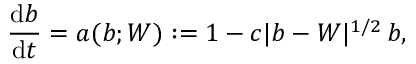Convert formula to latex. <formula><loc_0><loc_0><loc_500><loc_500>\frac { d b } { d t } = a ( b ; W ) \colon = 1 - c | b - W | ^ { 1 / 2 } \, b ,</formula> 